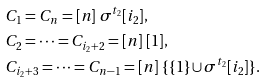<formula> <loc_0><loc_0><loc_500><loc_500>& C _ { 1 } = C _ { n } = [ n ] \ \sigma ^ { t _ { 2 } } [ i _ { 2 } ] , \\ & C _ { 2 } = \dots = C _ { i _ { 2 } + 2 } = [ n ] \ [ 1 ] , \\ & C _ { i _ { 2 } + 3 } = \dots = C _ { n - 1 } = [ n ] \ \{ \{ 1 \} \cup \sigma ^ { t _ { 2 } } [ i _ { 2 } ] \} .</formula> 